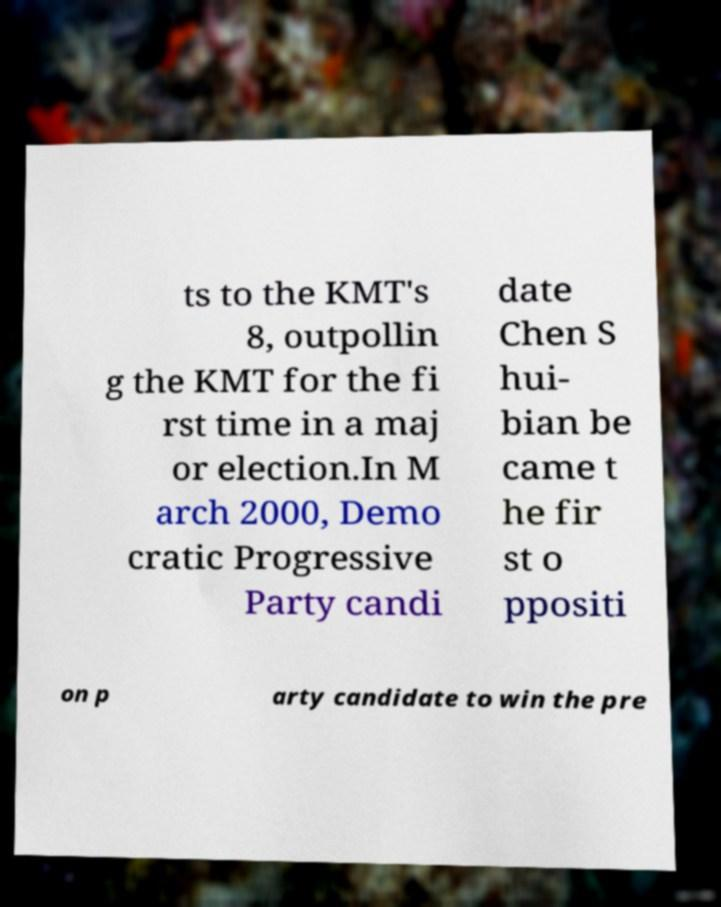Can you read and provide the text displayed in the image?This photo seems to have some interesting text. Can you extract and type it out for me? ts to the KMT's 8, outpollin g the KMT for the fi rst time in a maj or election.In M arch 2000, Demo cratic Progressive Party candi date Chen S hui- bian be came t he fir st o ppositi on p arty candidate to win the pre 